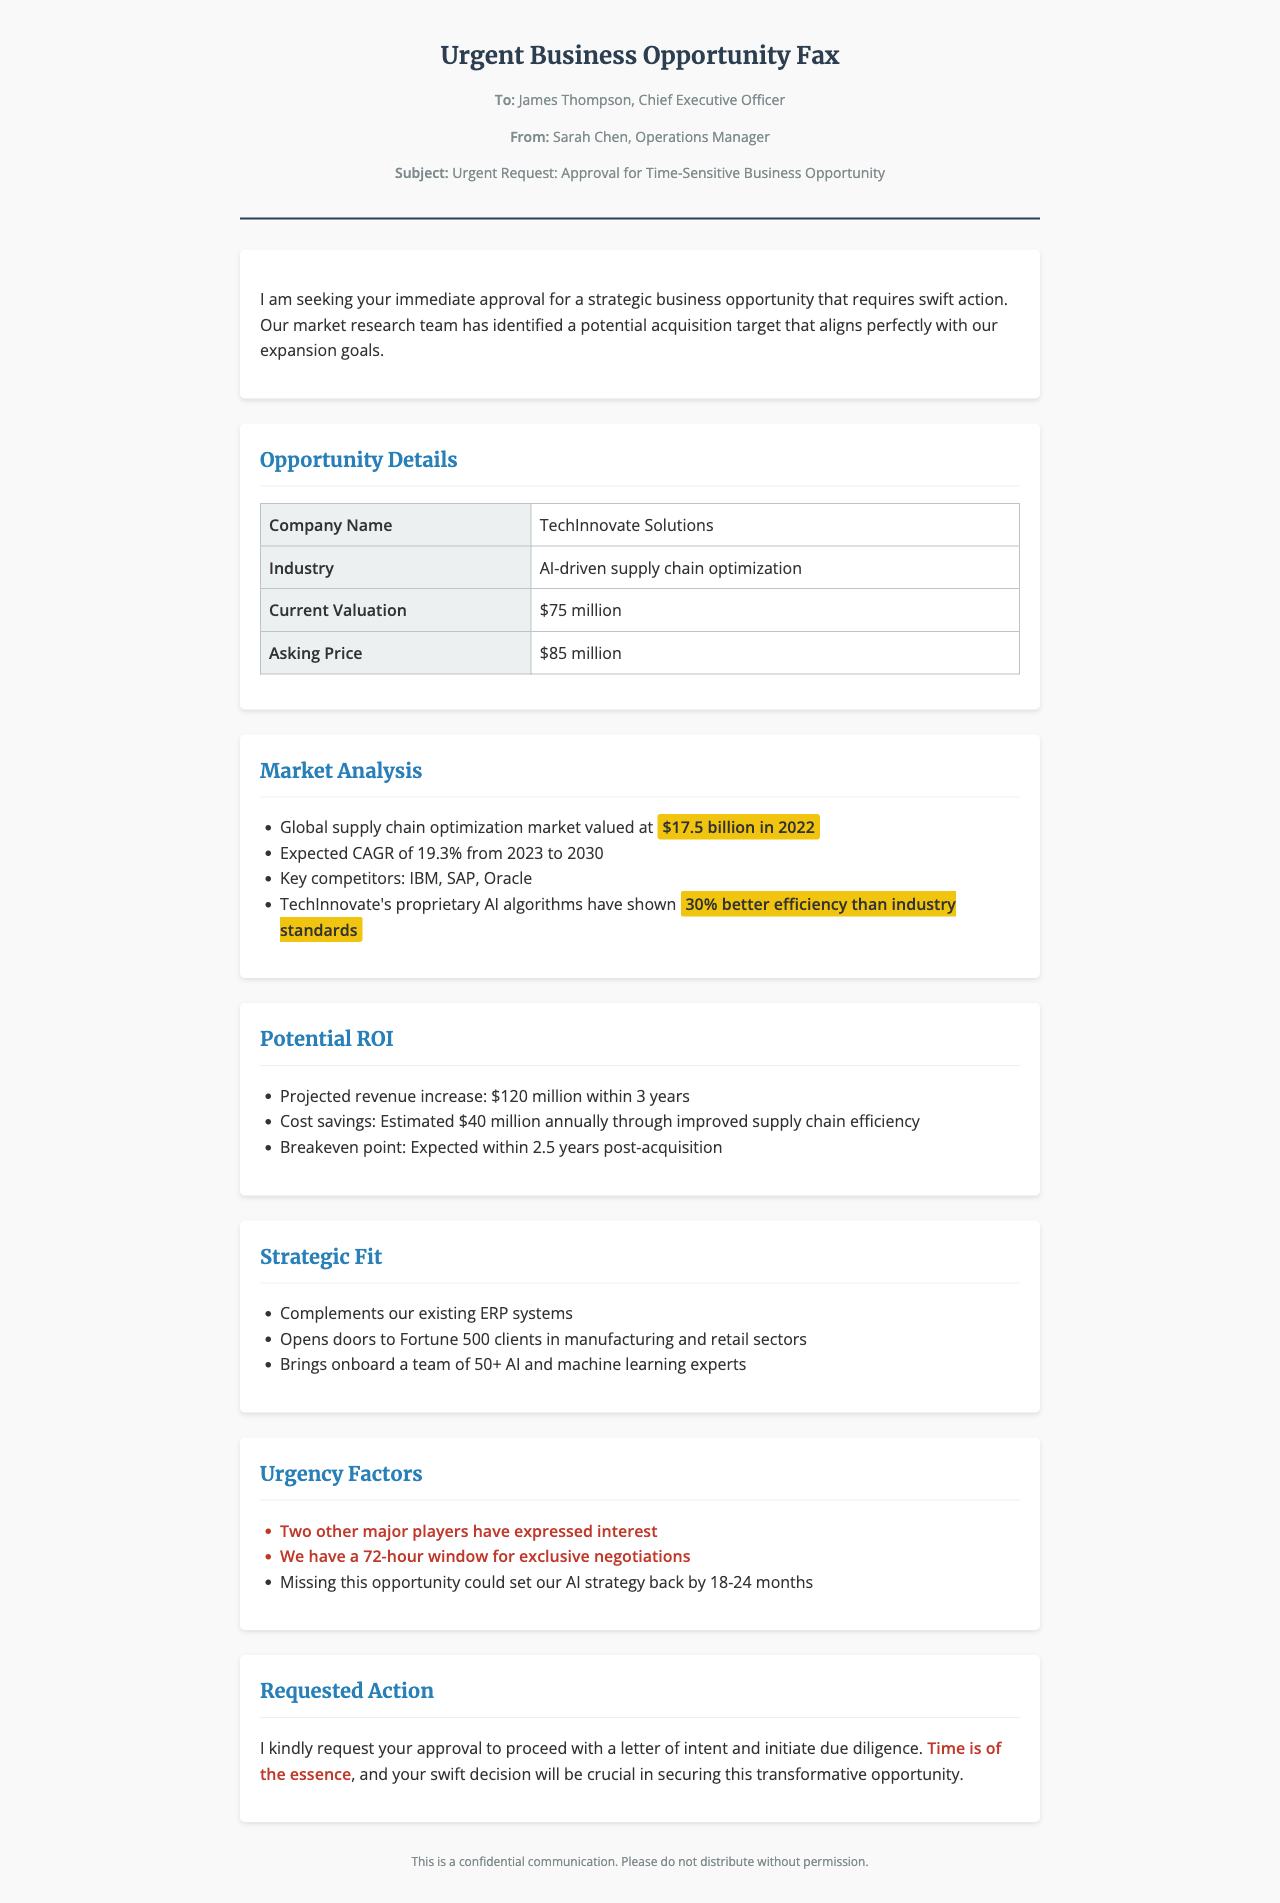What is the name of the company being proposed for acquisition? The company identified for acquisition is stated in the opportunity details section.
Answer: TechInnovate Solutions What is the industry of TechInnovate Solutions? The document specifies that the industry is mentioned in the opportunity details section.
Answer: AI-driven supply chain optimization What is the asking price for TechInnovate Solutions? The asking price is provided in the opportunity details table.
Answer: $85 million What is the projected revenue increase within 3 years? This information can be found in the potential ROI section of the document.
Answer: $120 million What is the expected breakeven point post-acquisition? The breakeven point is indicated in the potential ROI section.
Answer: Within 2.5 years What is the Global supply chain optimization market valued at in 2022? This data is included in the market analysis section of the document.
Answer: $17.5 billion What is the expected CAGR for the supply chain optimization market from 2023 to 2030? The CAGR is necessary for understanding market growth and is mentioned in the market analysis section.
Answer: 19.3% What urgency factor indicates competition for the acquisition? This indicates the competitive nature of the environment and is explicitly listed in the urgency factors section.
Answer: Two other major players have expressed interest What action is being requested from the CEO? This is clearly stated in the requested action section at the end of the document.
Answer: Approval to proceed with a letter of intent 